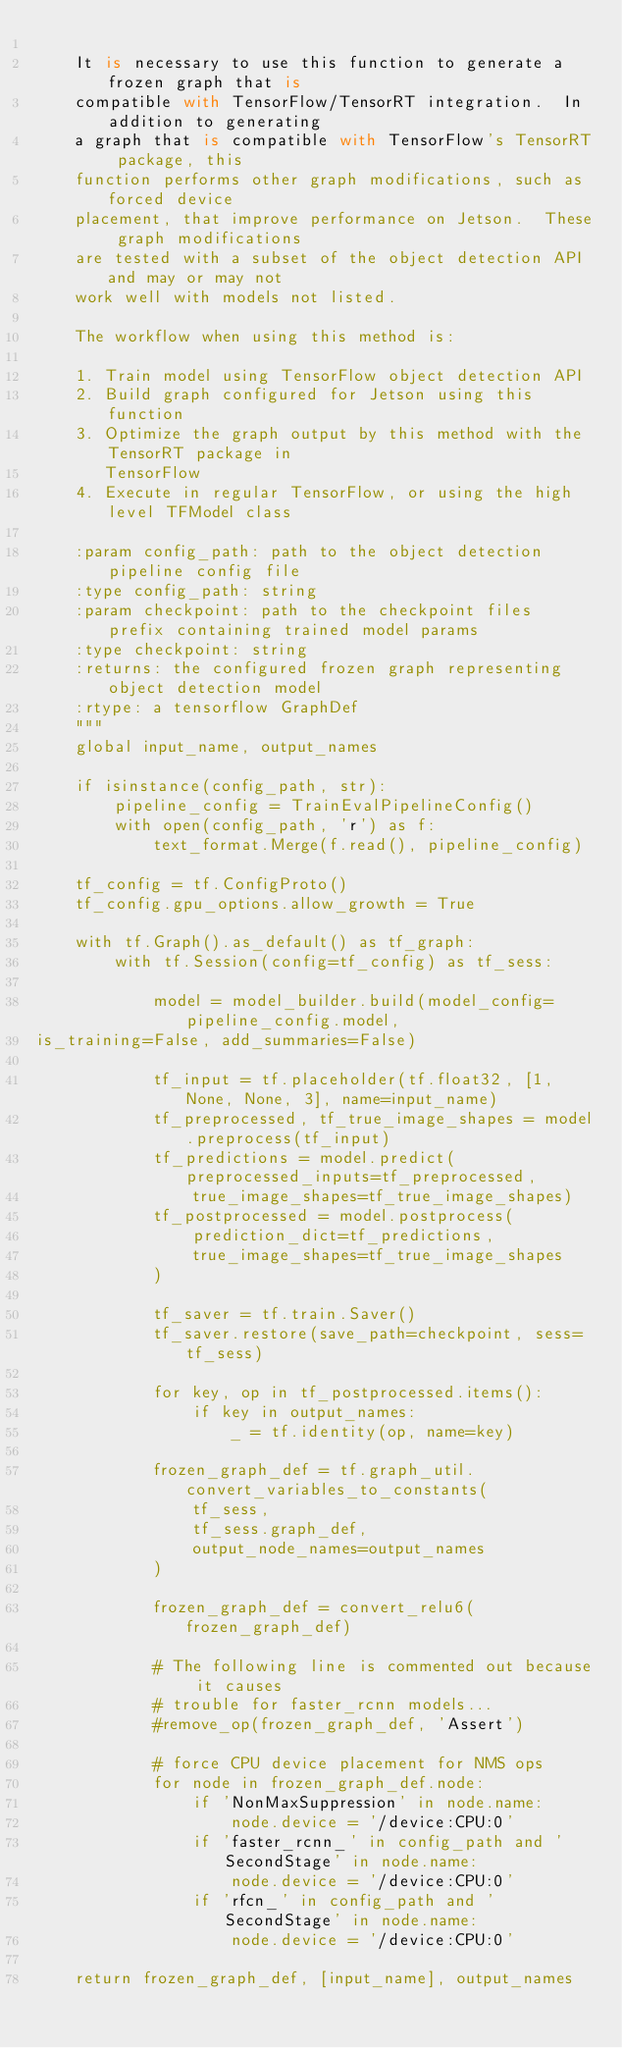<code> <loc_0><loc_0><loc_500><loc_500><_Python_>
    It is necessary to use this function to generate a frozen graph that is
    compatible with TensorFlow/TensorRT integration.  In addition to generating
    a graph that is compatible with TensorFlow's TensorRT package, this
    function performs other graph modifications, such as forced device
    placement, that improve performance on Jetson.  These graph modifications
    are tested with a subset of the object detection API and may or may not
    work well with models not listed.

    The workflow when using this method is:

    1. Train model using TensorFlow object detection API
    2. Build graph configured for Jetson using this function
    3. Optimize the graph output by this method with the TensorRT package in
       TensorFlow
    4. Execute in regular TensorFlow, or using the high level TFModel class

    :param config_path: path to the object detection pipeline config file
    :type config_path: string
    :param checkpoint: path to the checkpoint files prefix containing trained model params
    :type checkpoint: string
    :returns: the configured frozen graph representing object detection model
    :rtype: a tensorflow GraphDef
    """
    global input_name, output_names

    if isinstance(config_path, str):
        pipeline_config = TrainEvalPipelineConfig()
        with open(config_path, 'r') as f:
            text_format.Merge(f.read(), pipeline_config)

    tf_config = tf.ConfigProto()
    tf_config.gpu_options.allow_growth = True

    with tf.Graph().as_default() as tf_graph:
        with tf.Session(config=tf_config) as tf_sess:

            model = model_builder.build(model_config=pipeline_config.model,
is_training=False, add_summaries=False)

            tf_input = tf.placeholder(tf.float32, [1, None, None, 3], name=input_name)
            tf_preprocessed, tf_true_image_shapes = model.preprocess(tf_input)
            tf_predictions = model.predict(preprocessed_inputs=tf_preprocessed,
                true_image_shapes=tf_true_image_shapes)
            tf_postprocessed = model.postprocess(
                prediction_dict=tf_predictions,
                true_image_shapes=tf_true_image_shapes
            )

            tf_saver = tf.train.Saver()
            tf_saver.restore(save_path=checkpoint, sess=tf_sess)

            for key, op in tf_postprocessed.items():
                if key in output_names:
                    _ = tf.identity(op, name=key)

            frozen_graph_def = tf.graph_util.convert_variables_to_constants(
                tf_sess,
                tf_sess.graph_def,
                output_node_names=output_names
            )

            frozen_graph_def = convert_relu6(frozen_graph_def)

            # The following line is commented out because it causes
            # trouble for faster_rcnn models...
            #remove_op(frozen_graph_def, 'Assert')

            # force CPU device placement for NMS ops
            for node in frozen_graph_def.node:
                if 'NonMaxSuppression' in node.name:
                    node.device = '/device:CPU:0'
                if 'faster_rcnn_' in config_path and 'SecondStage' in node.name:
                    node.device = '/device:CPU:0'
                if 'rfcn_' in config_path and 'SecondStage' in node.name:
                    node.device = '/device:CPU:0'

    return frozen_graph_def, [input_name], output_names
</code> 